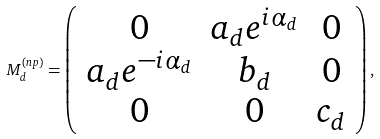<formula> <loc_0><loc_0><loc_500><loc_500>M _ { d } ^ { ( n p ) } = \left ( \begin{array} { c c c } 0 & a _ { d } e ^ { i \alpha _ { d } } & 0 \\ a _ { d } e ^ { - i \alpha _ { d } } & b _ { d } & 0 \\ 0 & 0 & c _ { d } \end{array} \right ) ,</formula> 